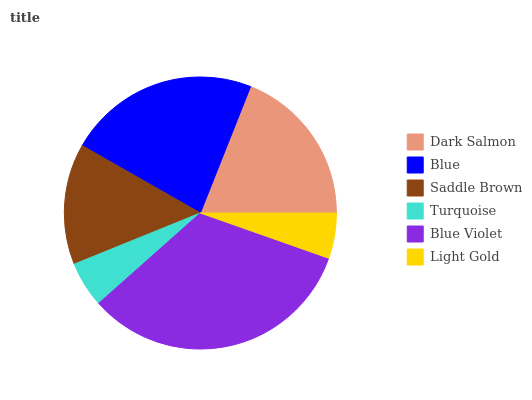Is Light Gold the minimum?
Answer yes or no. Yes. Is Blue Violet the maximum?
Answer yes or no. Yes. Is Blue the minimum?
Answer yes or no. No. Is Blue the maximum?
Answer yes or no. No. Is Blue greater than Dark Salmon?
Answer yes or no. Yes. Is Dark Salmon less than Blue?
Answer yes or no. Yes. Is Dark Salmon greater than Blue?
Answer yes or no. No. Is Blue less than Dark Salmon?
Answer yes or no. No. Is Dark Salmon the high median?
Answer yes or no. Yes. Is Saddle Brown the low median?
Answer yes or no. Yes. Is Light Gold the high median?
Answer yes or no. No. Is Dark Salmon the low median?
Answer yes or no. No. 